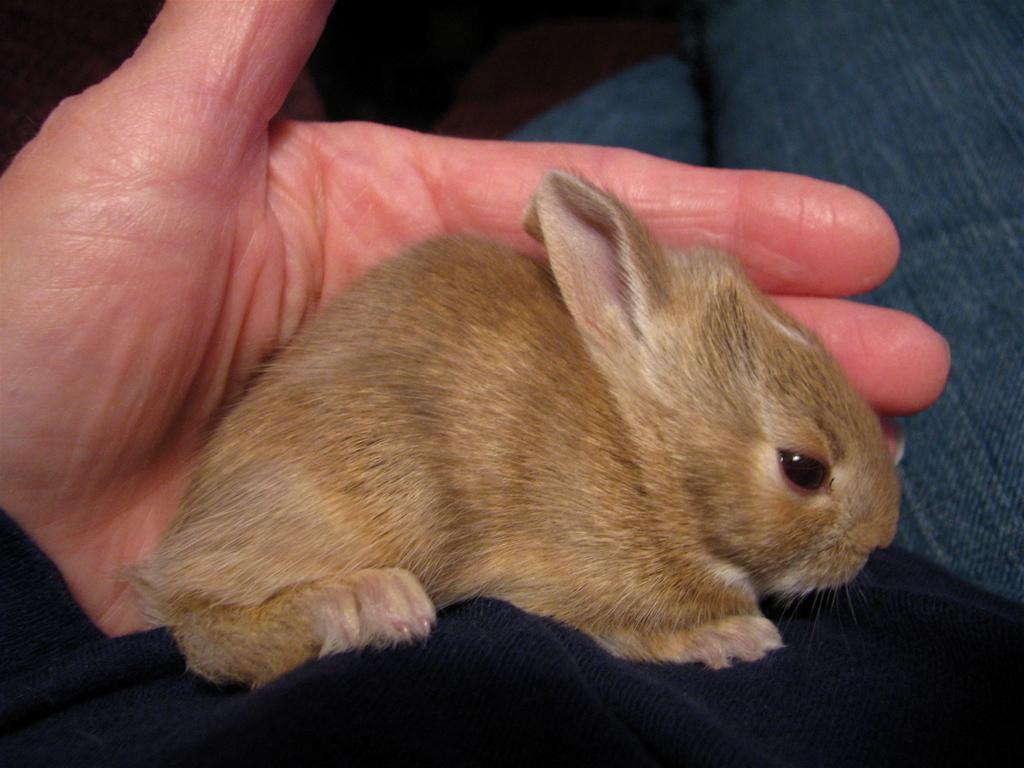Describe this image in one or two sentences. In this image there is a rat on the body of a person. 